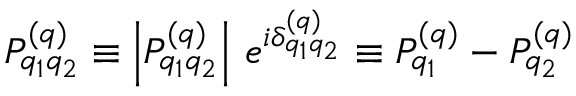Convert formula to latex. <formula><loc_0><loc_0><loc_500><loc_500>P _ { q _ { 1 } q _ { 2 } } ^ { ( q ) } \equiv \left | P _ { q _ { 1 } q _ { 2 } } ^ { ( q ) } \right | \, e ^ { i \delta _ { q _ { 1 } q _ { 2 } } ^ { ( q ) } } \equiv P _ { q _ { 1 } } ^ { ( q ) } - P _ { q _ { 2 } } ^ { ( q ) }</formula> 